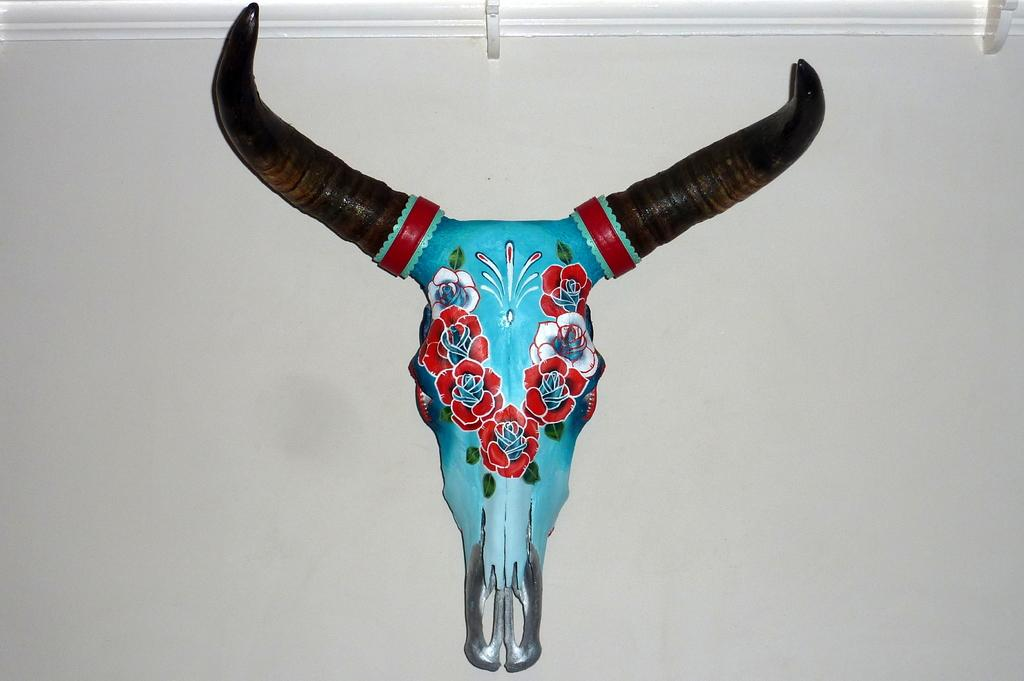What is the main subject of the image? The main subject of the image is a bull skull. Is there anything unique about the bull skull? Yes, the bull skull has a painting attached to it. Where is the bull skull located in the image? The bull skull is on a white wall. Are there any other objects on the wall in the image? Yes, there are two objects attached to the wall at the top of the image. How many brothers are depicted in the painting on the bull skull? There are no brothers depicted in the painting on the bull skull, as the painting is not described in the facts. 